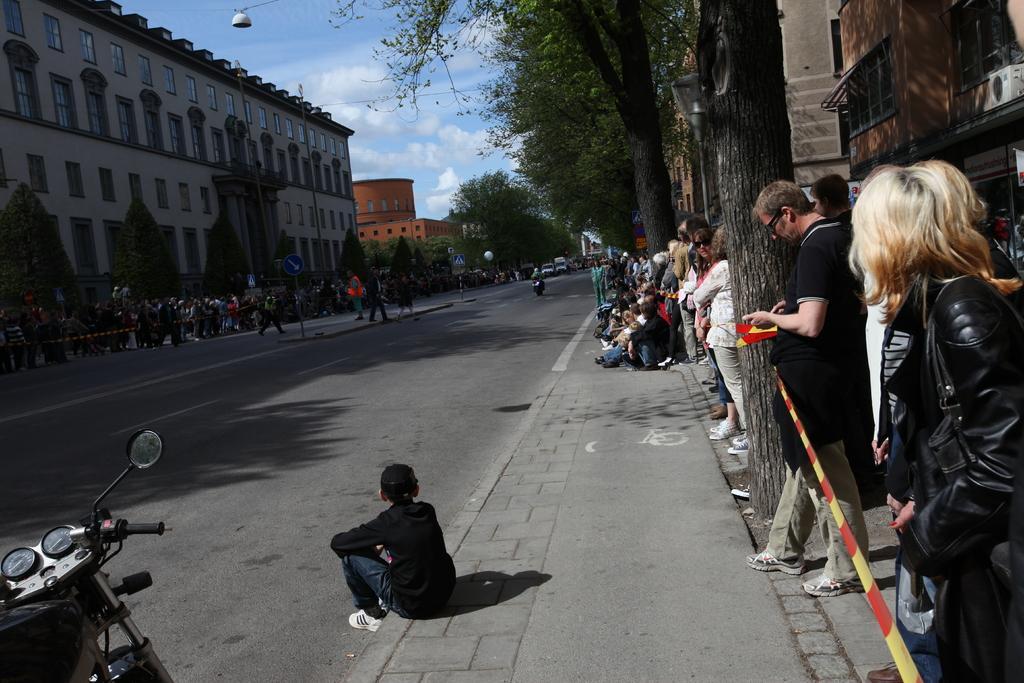Can you describe this image briefly? In this image we can see a group of people. We can also see a signboard, some poles tied with ribbons, street lamps, some vehicles on the road, the bark of a tree, a group of trees, some buildings with windows, poles, wire and the sky which looks cloudy. On the bottom of the image we can see a person sitting. 